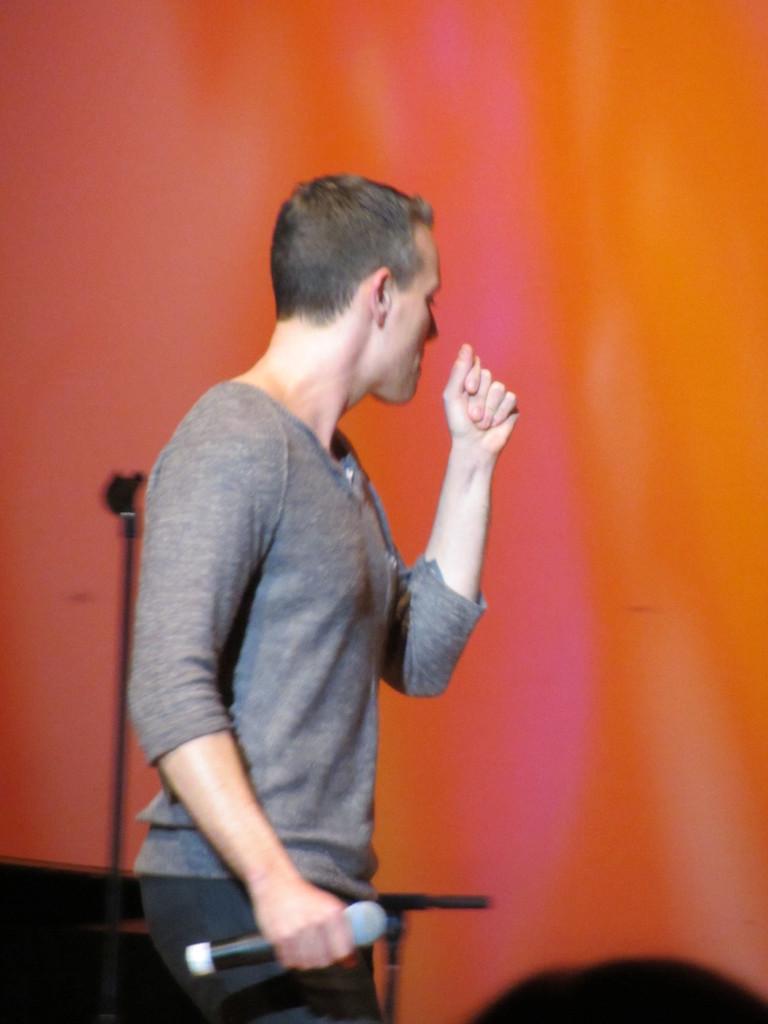Describe this image in one or two sentences. In this image I can see a man wearing a t-shirt, holding a mike in the hand and standing facing towards the right side. In the background there is a metal object. The background is blurred. 